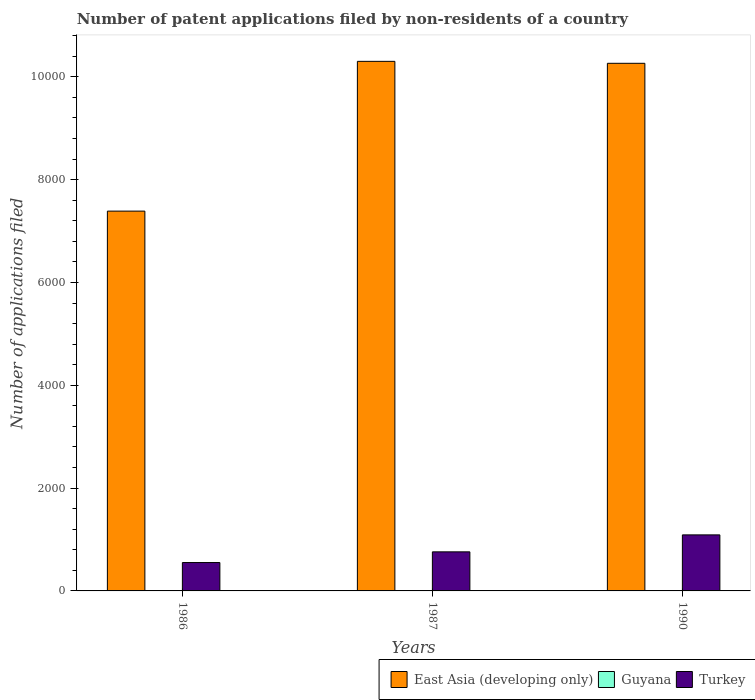How many groups of bars are there?
Offer a very short reply. 3. Are the number of bars on each tick of the X-axis equal?
Provide a short and direct response. Yes. How many bars are there on the 2nd tick from the left?
Provide a succinct answer. 3. How many bars are there on the 3rd tick from the right?
Provide a short and direct response. 3. What is the label of the 2nd group of bars from the left?
Provide a succinct answer. 1987. In how many cases, is the number of bars for a given year not equal to the number of legend labels?
Make the answer very short. 0. What is the number of applications filed in East Asia (developing only) in 1987?
Your response must be concise. 1.03e+04. Across all years, what is the maximum number of applications filed in East Asia (developing only)?
Provide a succinct answer. 1.03e+04. Across all years, what is the minimum number of applications filed in Turkey?
Offer a very short reply. 552. In which year was the number of applications filed in Turkey maximum?
Offer a very short reply. 1990. In which year was the number of applications filed in East Asia (developing only) minimum?
Your answer should be very brief. 1986. What is the total number of applications filed in Turkey in the graph?
Provide a succinct answer. 2402. What is the difference between the number of applications filed in Turkey in 1986 and that in 1990?
Ensure brevity in your answer.  -538. What is the difference between the number of applications filed in East Asia (developing only) in 1987 and the number of applications filed in Turkey in 1990?
Offer a very short reply. 9210. What is the average number of applications filed in Guyana per year?
Your answer should be very brief. 5.67. In the year 1986, what is the difference between the number of applications filed in Turkey and number of applications filed in Guyana?
Your answer should be compact. 544. Is the difference between the number of applications filed in Turkey in 1986 and 1987 greater than the difference between the number of applications filed in Guyana in 1986 and 1987?
Keep it short and to the point. No. What is the difference between the highest and the lowest number of applications filed in Turkey?
Your answer should be very brief. 538. In how many years, is the number of applications filed in East Asia (developing only) greater than the average number of applications filed in East Asia (developing only) taken over all years?
Keep it short and to the point. 2. What does the 3rd bar from the left in 1987 represents?
Make the answer very short. Turkey. What does the 1st bar from the right in 1987 represents?
Provide a succinct answer. Turkey. Is it the case that in every year, the sum of the number of applications filed in Turkey and number of applications filed in East Asia (developing only) is greater than the number of applications filed in Guyana?
Provide a succinct answer. Yes. How many bars are there?
Ensure brevity in your answer.  9. How many years are there in the graph?
Provide a succinct answer. 3. Are the values on the major ticks of Y-axis written in scientific E-notation?
Your response must be concise. No. Where does the legend appear in the graph?
Make the answer very short. Bottom right. How many legend labels are there?
Ensure brevity in your answer.  3. What is the title of the graph?
Your response must be concise. Number of patent applications filed by non-residents of a country. What is the label or title of the Y-axis?
Your answer should be very brief. Number of applications filed. What is the Number of applications filed in East Asia (developing only) in 1986?
Offer a terse response. 7387. What is the Number of applications filed in Turkey in 1986?
Ensure brevity in your answer.  552. What is the Number of applications filed of East Asia (developing only) in 1987?
Your response must be concise. 1.03e+04. What is the Number of applications filed of Turkey in 1987?
Offer a very short reply. 760. What is the Number of applications filed in East Asia (developing only) in 1990?
Make the answer very short. 1.03e+04. What is the Number of applications filed in Guyana in 1990?
Your response must be concise. 6. What is the Number of applications filed of Turkey in 1990?
Your answer should be compact. 1090. Across all years, what is the maximum Number of applications filed of East Asia (developing only)?
Give a very brief answer. 1.03e+04. Across all years, what is the maximum Number of applications filed in Turkey?
Make the answer very short. 1090. Across all years, what is the minimum Number of applications filed of East Asia (developing only)?
Your answer should be compact. 7387. Across all years, what is the minimum Number of applications filed in Turkey?
Your answer should be compact. 552. What is the total Number of applications filed in East Asia (developing only) in the graph?
Make the answer very short. 2.79e+04. What is the total Number of applications filed of Turkey in the graph?
Offer a very short reply. 2402. What is the difference between the Number of applications filed of East Asia (developing only) in 1986 and that in 1987?
Your answer should be compact. -2913. What is the difference between the Number of applications filed in Turkey in 1986 and that in 1987?
Give a very brief answer. -208. What is the difference between the Number of applications filed in East Asia (developing only) in 1986 and that in 1990?
Provide a short and direct response. -2875. What is the difference between the Number of applications filed in Turkey in 1986 and that in 1990?
Offer a very short reply. -538. What is the difference between the Number of applications filed in East Asia (developing only) in 1987 and that in 1990?
Ensure brevity in your answer.  38. What is the difference between the Number of applications filed in Turkey in 1987 and that in 1990?
Offer a terse response. -330. What is the difference between the Number of applications filed in East Asia (developing only) in 1986 and the Number of applications filed in Guyana in 1987?
Your response must be concise. 7384. What is the difference between the Number of applications filed in East Asia (developing only) in 1986 and the Number of applications filed in Turkey in 1987?
Provide a short and direct response. 6627. What is the difference between the Number of applications filed of Guyana in 1986 and the Number of applications filed of Turkey in 1987?
Give a very brief answer. -752. What is the difference between the Number of applications filed in East Asia (developing only) in 1986 and the Number of applications filed in Guyana in 1990?
Offer a terse response. 7381. What is the difference between the Number of applications filed of East Asia (developing only) in 1986 and the Number of applications filed of Turkey in 1990?
Your response must be concise. 6297. What is the difference between the Number of applications filed in Guyana in 1986 and the Number of applications filed in Turkey in 1990?
Offer a very short reply. -1082. What is the difference between the Number of applications filed of East Asia (developing only) in 1987 and the Number of applications filed of Guyana in 1990?
Ensure brevity in your answer.  1.03e+04. What is the difference between the Number of applications filed in East Asia (developing only) in 1987 and the Number of applications filed in Turkey in 1990?
Offer a very short reply. 9210. What is the difference between the Number of applications filed of Guyana in 1987 and the Number of applications filed of Turkey in 1990?
Make the answer very short. -1087. What is the average Number of applications filed of East Asia (developing only) per year?
Provide a succinct answer. 9316.33. What is the average Number of applications filed in Guyana per year?
Keep it short and to the point. 5.67. What is the average Number of applications filed of Turkey per year?
Ensure brevity in your answer.  800.67. In the year 1986, what is the difference between the Number of applications filed of East Asia (developing only) and Number of applications filed of Guyana?
Give a very brief answer. 7379. In the year 1986, what is the difference between the Number of applications filed in East Asia (developing only) and Number of applications filed in Turkey?
Offer a very short reply. 6835. In the year 1986, what is the difference between the Number of applications filed in Guyana and Number of applications filed in Turkey?
Give a very brief answer. -544. In the year 1987, what is the difference between the Number of applications filed in East Asia (developing only) and Number of applications filed in Guyana?
Offer a very short reply. 1.03e+04. In the year 1987, what is the difference between the Number of applications filed in East Asia (developing only) and Number of applications filed in Turkey?
Provide a succinct answer. 9540. In the year 1987, what is the difference between the Number of applications filed in Guyana and Number of applications filed in Turkey?
Make the answer very short. -757. In the year 1990, what is the difference between the Number of applications filed of East Asia (developing only) and Number of applications filed of Guyana?
Make the answer very short. 1.03e+04. In the year 1990, what is the difference between the Number of applications filed of East Asia (developing only) and Number of applications filed of Turkey?
Provide a succinct answer. 9172. In the year 1990, what is the difference between the Number of applications filed in Guyana and Number of applications filed in Turkey?
Your response must be concise. -1084. What is the ratio of the Number of applications filed in East Asia (developing only) in 1986 to that in 1987?
Provide a short and direct response. 0.72. What is the ratio of the Number of applications filed of Guyana in 1986 to that in 1987?
Your answer should be compact. 2.67. What is the ratio of the Number of applications filed in Turkey in 1986 to that in 1987?
Make the answer very short. 0.73. What is the ratio of the Number of applications filed in East Asia (developing only) in 1986 to that in 1990?
Provide a short and direct response. 0.72. What is the ratio of the Number of applications filed in Turkey in 1986 to that in 1990?
Make the answer very short. 0.51. What is the ratio of the Number of applications filed of Guyana in 1987 to that in 1990?
Keep it short and to the point. 0.5. What is the ratio of the Number of applications filed in Turkey in 1987 to that in 1990?
Offer a terse response. 0.7. What is the difference between the highest and the second highest Number of applications filed in Turkey?
Provide a succinct answer. 330. What is the difference between the highest and the lowest Number of applications filed of East Asia (developing only)?
Your answer should be very brief. 2913. What is the difference between the highest and the lowest Number of applications filed of Turkey?
Offer a terse response. 538. 